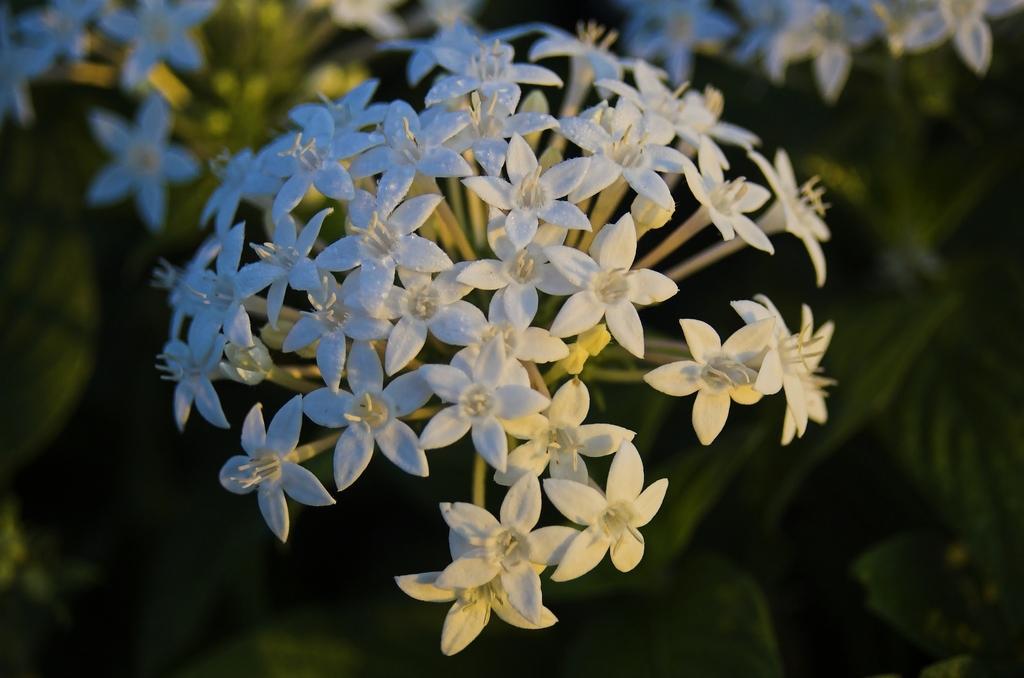Please provide a concise description of this image. In the picture we can see some plants with a group of white color flowers to it. 